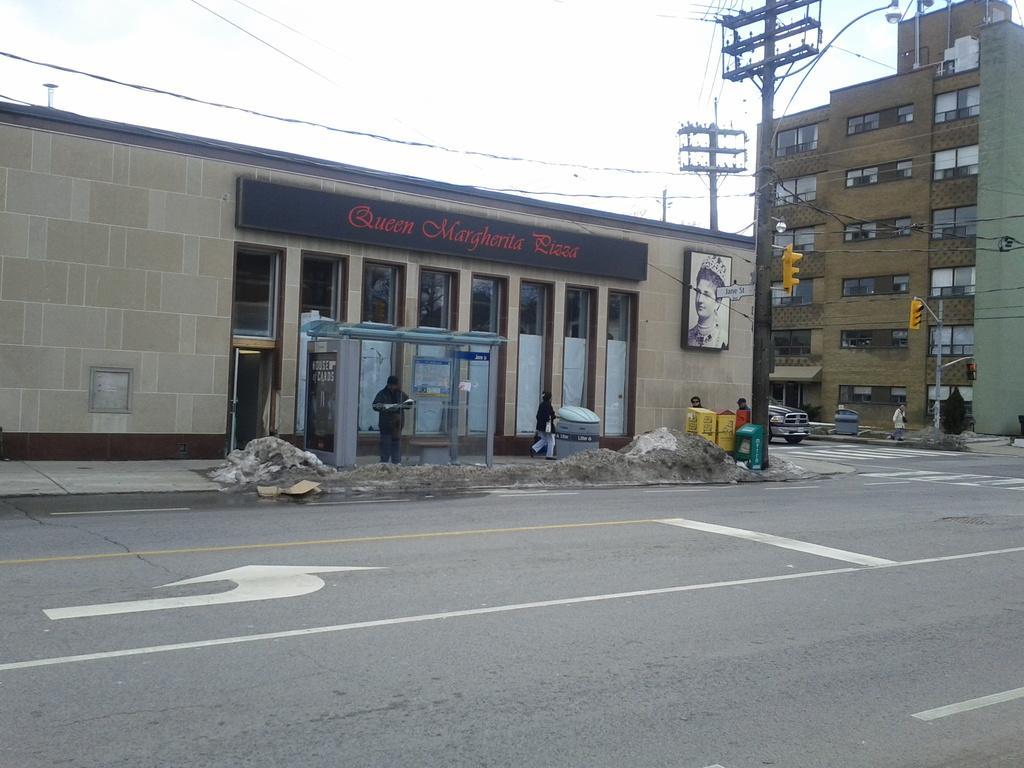Describe this image in one or two sentences. In this picture we can see road and bins. There are people and we can see traffic signals on poles, wires, boards, vehicle and buildings, In the background of the image we can see the sky. 